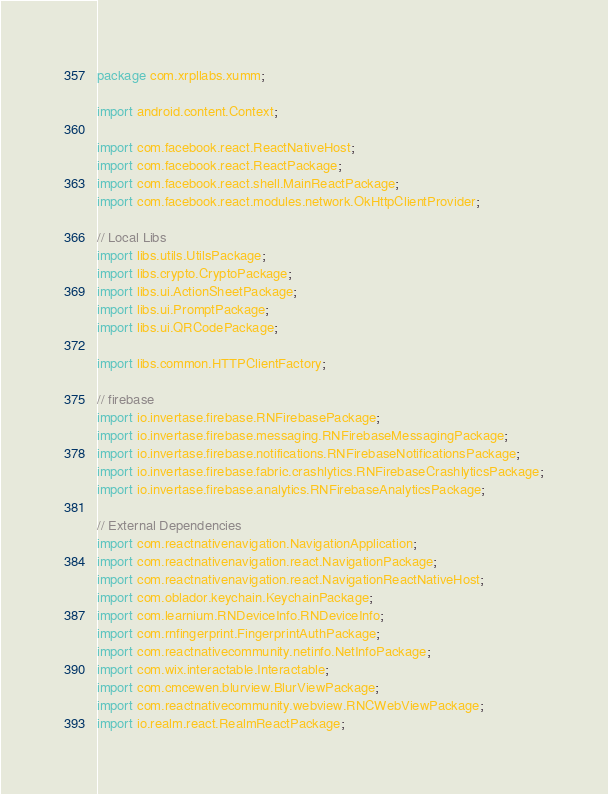<code> <loc_0><loc_0><loc_500><loc_500><_Java_>package com.xrpllabs.xumm;

import android.content.Context;

import com.facebook.react.ReactNativeHost;
import com.facebook.react.ReactPackage;
import com.facebook.react.shell.MainReactPackage;
import com.facebook.react.modules.network.OkHttpClientProvider;

// Local Libs
import libs.utils.UtilsPackage;
import libs.crypto.CryptoPackage;
import libs.ui.ActionSheetPackage;
import libs.ui.PromptPackage;
import libs.ui.QRCodePackage;

import libs.common.HTTPClientFactory;

// firebase
import io.invertase.firebase.RNFirebasePackage;
import io.invertase.firebase.messaging.RNFirebaseMessagingPackage;
import io.invertase.firebase.notifications.RNFirebaseNotificationsPackage;
import io.invertase.firebase.fabric.crashlytics.RNFirebaseCrashlyticsPackage;
import io.invertase.firebase.analytics.RNFirebaseAnalyticsPackage;

// External Dependencies
import com.reactnativenavigation.NavigationApplication;
import com.reactnativenavigation.react.NavigationPackage;
import com.reactnativenavigation.react.NavigationReactNativeHost;
import com.oblador.keychain.KeychainPackage;
import com.learnium.RNDeviceInfo.RNDeviceInfo;
import com.rnfingerprint.FingerprintAuthPackage;
import com.reactnativecommunity.netinfo.NetInfoPackage;
import com.wix.interactable.Interactable;
import com.cmcewen.blurview.BlurViewPackage;
import com.reactnativecommunity.webview.RNCWebViewPackage;
import io.realm.react.RealmReactPackage;</code> 